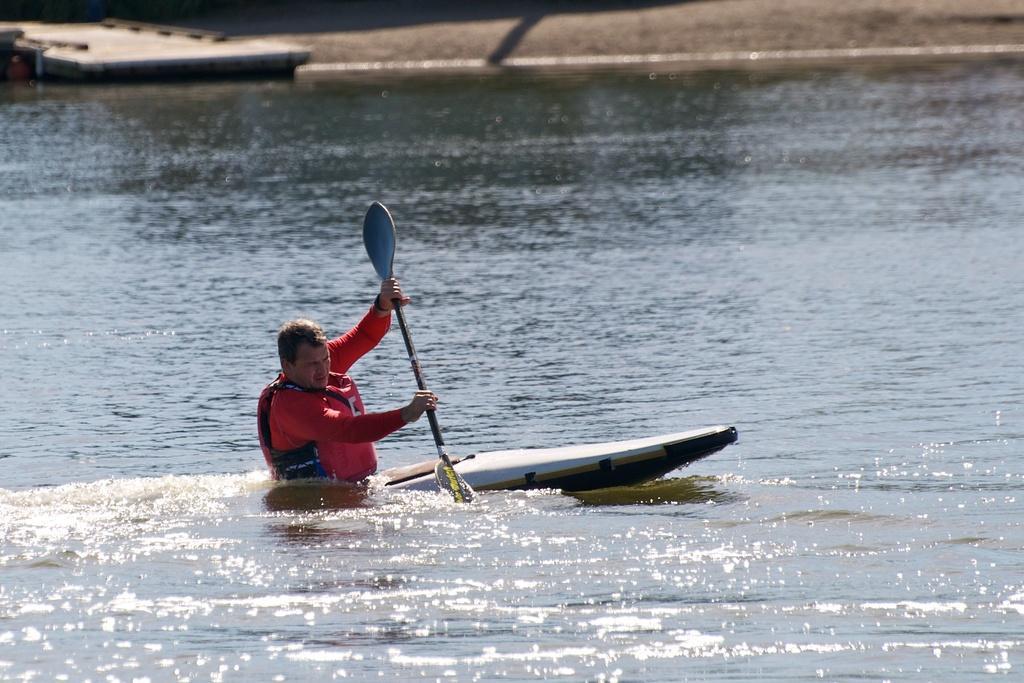How would you summarize this image in a sentence or two? This picture is taken from outside of the city. In this image, in the middle, we can see a man sitting on the boat and holding a stick in his hand and the boat is drowning in the water. In the background, we can see a bridge and a sand, at the bottom, we can see water in a lake. 